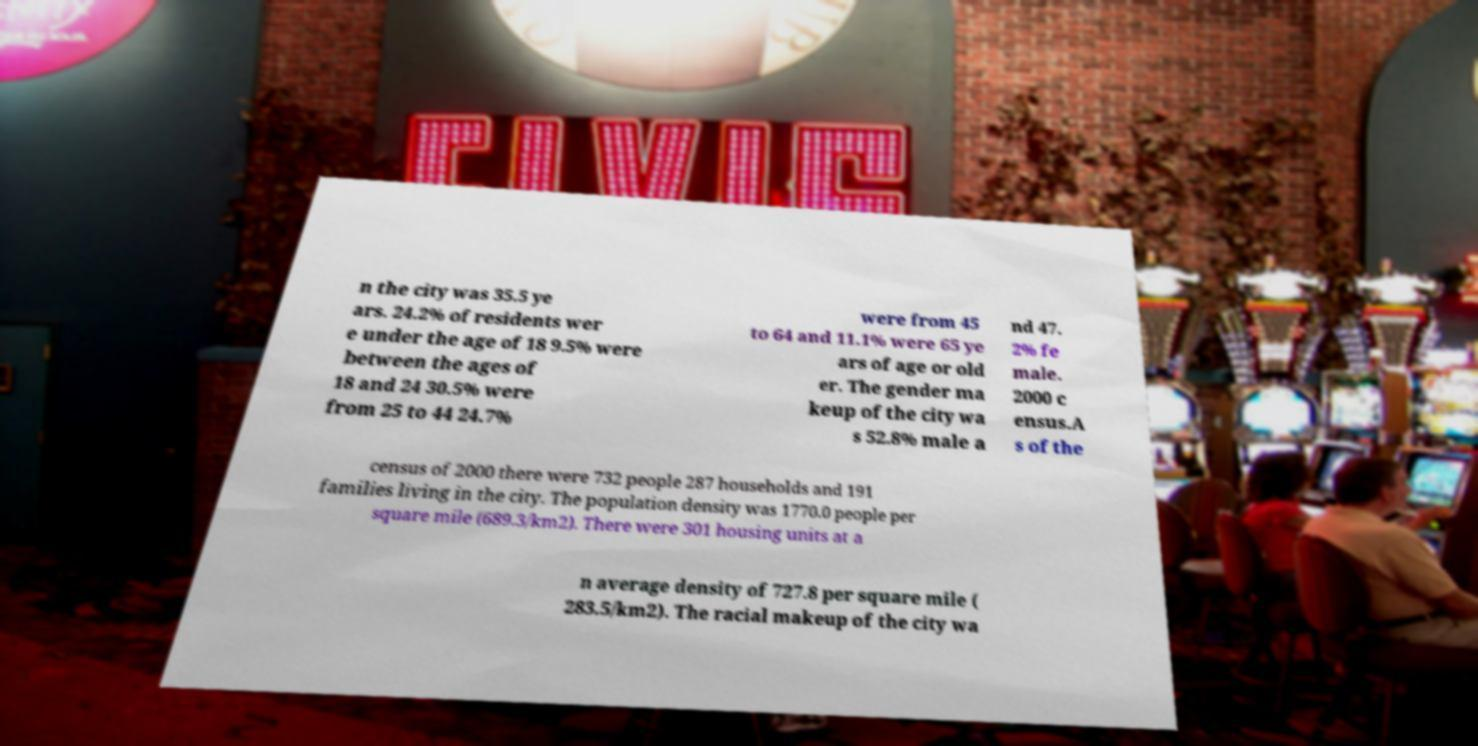Please read and relay the text visible in this image. What does it say? n the city was 35.5 ye ars. 24.2% of residents wer e under the age of 18 9.5% were between the ages of 18 and 24 30.5% were from 25 to 44 24.7% were from 45 to 64 and 11.1% were 65 ye ars of age or old er. The gender ma keup of the city wa s 52.8% male a nd 47. 2% fe male. 2000 c ensus.A s of the census of 2000 there were 732 people 287 households and 191 families living in the city. The population density was 1770.0 people per square mile (689.3/km2). There were 301 housing units at a n average density of 727.8 per square mile ( 283.5/km2). The racial makeup of the city wa 